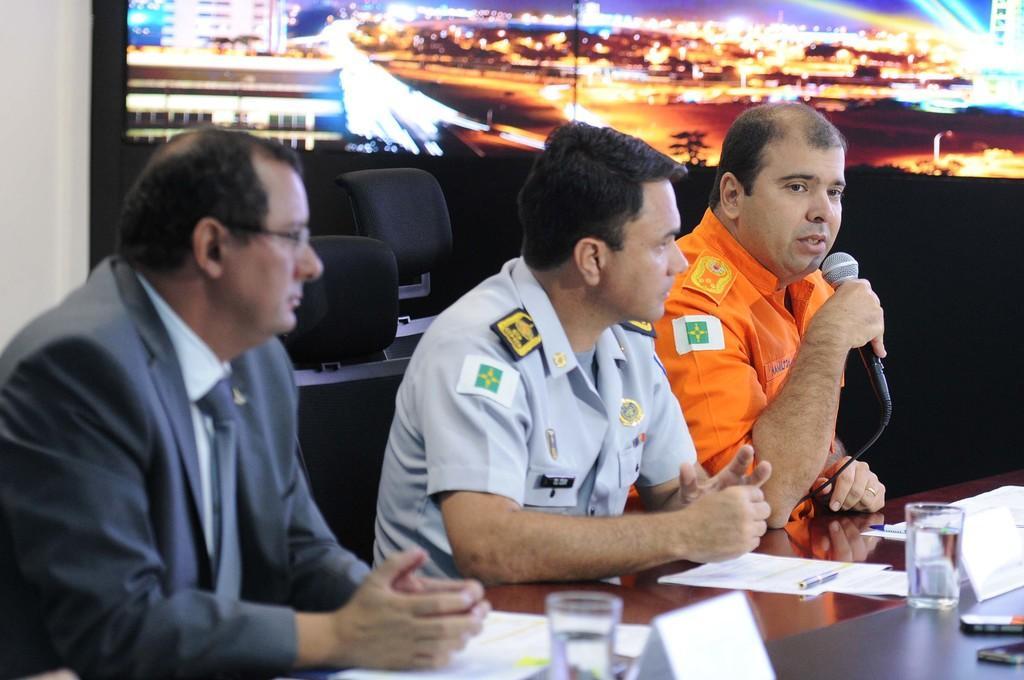In one or two sentences, can you explain what this image depicts? In this image we can see few people. A person is speaking into a microphone. There are many objects on the table. There is a screen in the image. On the screen we can see many buildings, houses and lights. There are few chairs in the image. 